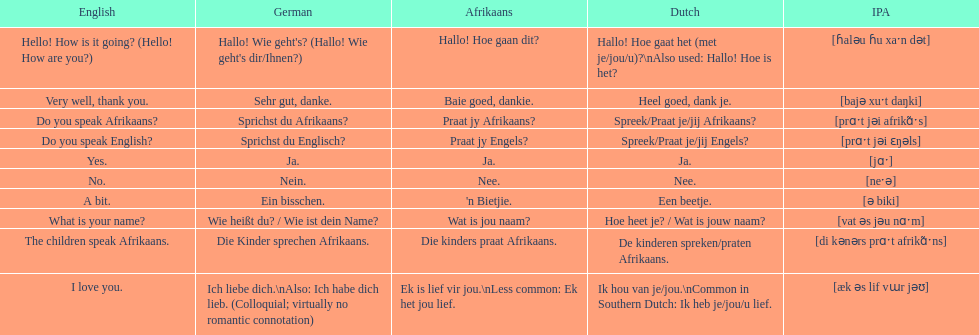How do you say 'yes' in afrikaans? Ja. 